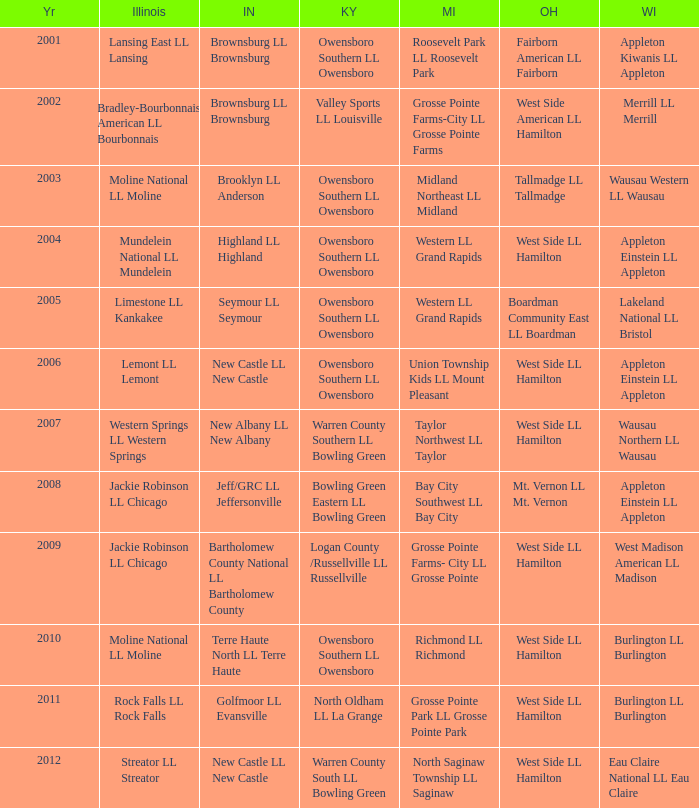What was the little league team from Kentucky when the little league team from Indiana and Wisconsin were Brownsburg LL Brownsburg and Merrill LL Merrill? Valley Sports LL Louisville. 